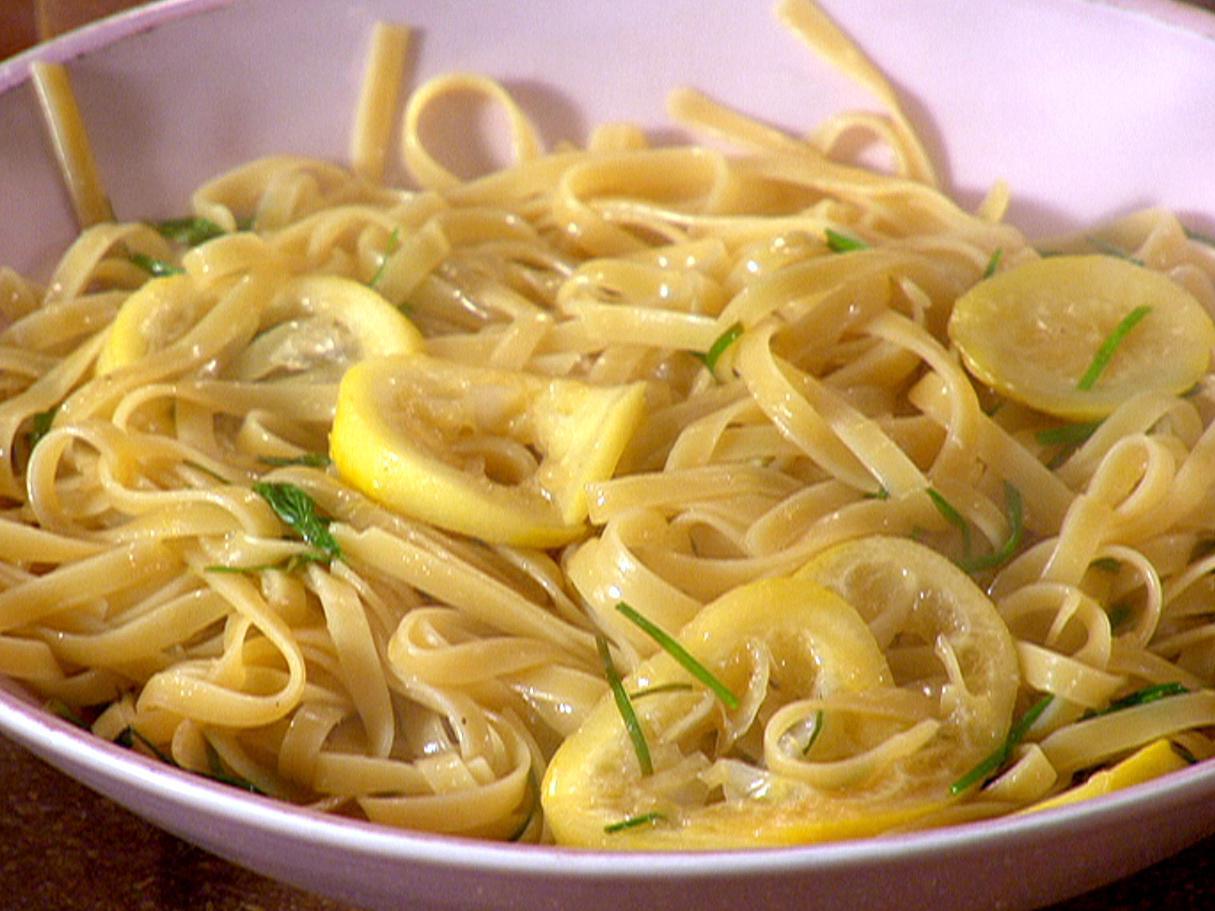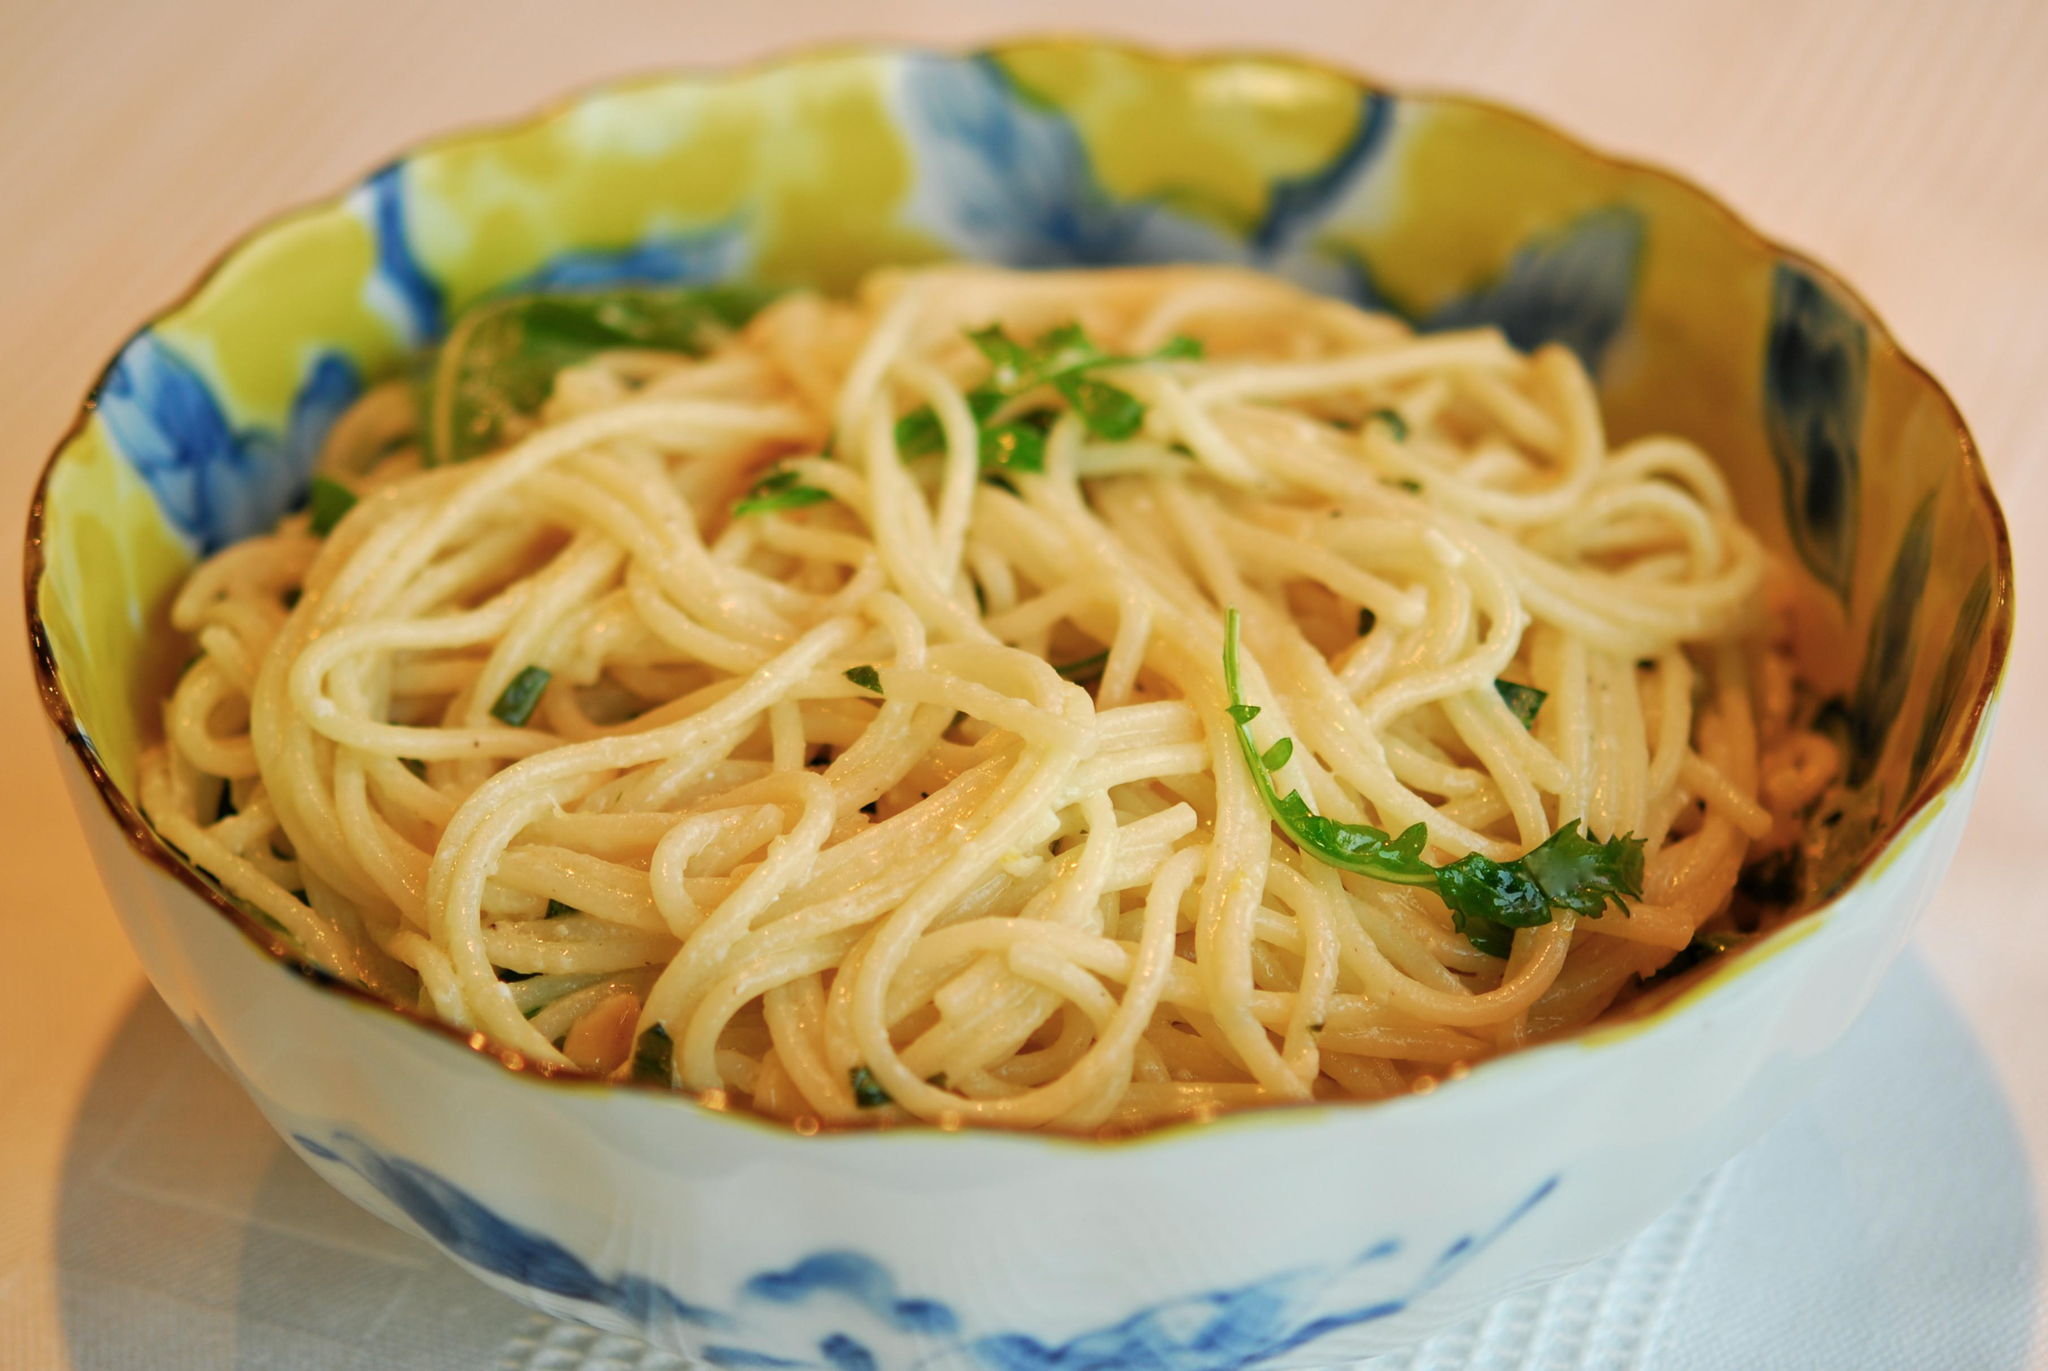The first image is the image on the left, the second image is the image on the right. Considering the images on both sides, is "One image shows a pasta dish topped with sliced lemon." valid? Answer yes or no. Yes. The first image is the image on the left, the second image is the image on the right. Evaluate the accuracy of this statement regarding the images: "A silver utinsil is sitting in the bowl in one of the images.". Is it true? Answer yes or no. No. 